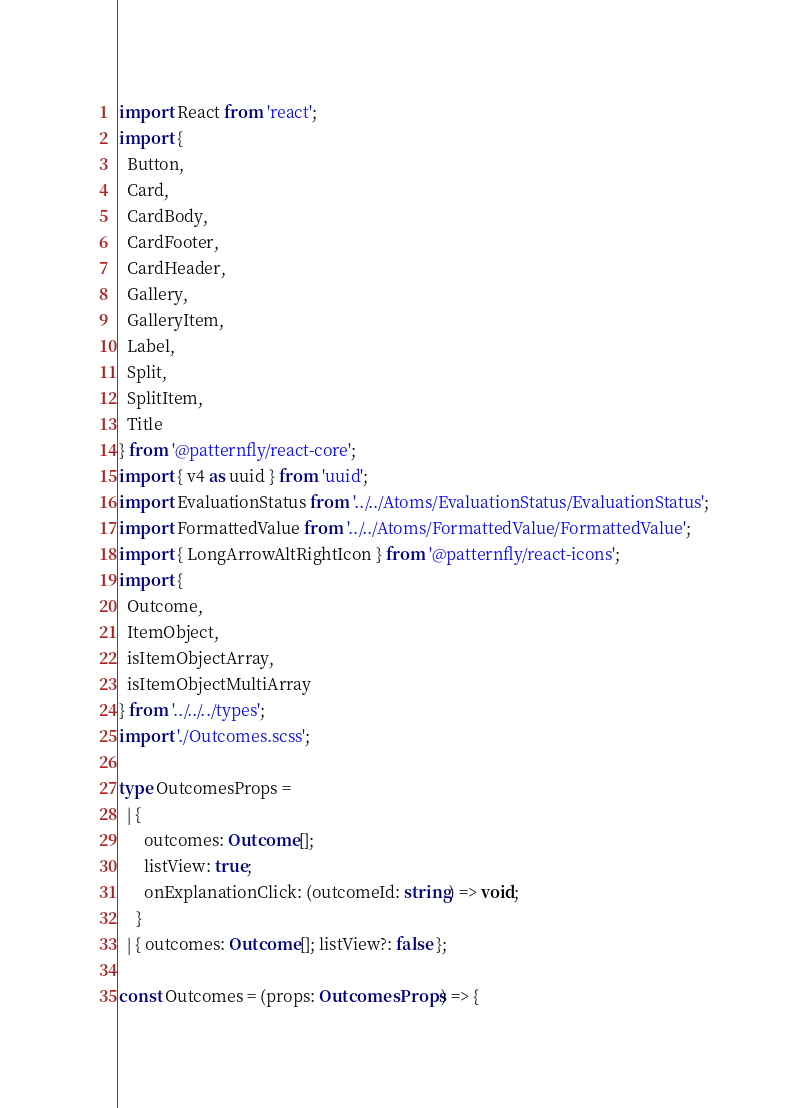<code> <loc_0><loc_0><loc_500><loc_500><_TypeScript_>import React from 'react';
import {
  Button,
  Card,
  CardBody,
  CardFooter,
  CardHeader,
  Gallery,
  GalleryItem,
  Label,
  Split,
  SplitItem,
  Title
} from '@patternfly/react-core';
import { v4 as uuid } from 'uuid';
import EvaluationStatus from '../../Atoms/EvaluationStatus/EvaluationStatus';
import FormattedValue from '../../Atoms/FormattedValue/FormattedValue';
import { LongArrowAltRightIcon } from '@patternfly/react-icons';
import {
  Outcome,
  ItemObject,
  isItemObjectArray,
  isItemObjectMultiArray
} from '../../../types';
import './Outcomes.scss';

type OutcomesProps =
  | {
      outcomes: Outcome[];
      listView: true;
      onExplanationClick: (outcomeId: string) => void;
    }
  | { outcomes: Outcome[]; listView?: false };

const Outcomes = (props: OutcomesProps) => {</code> 